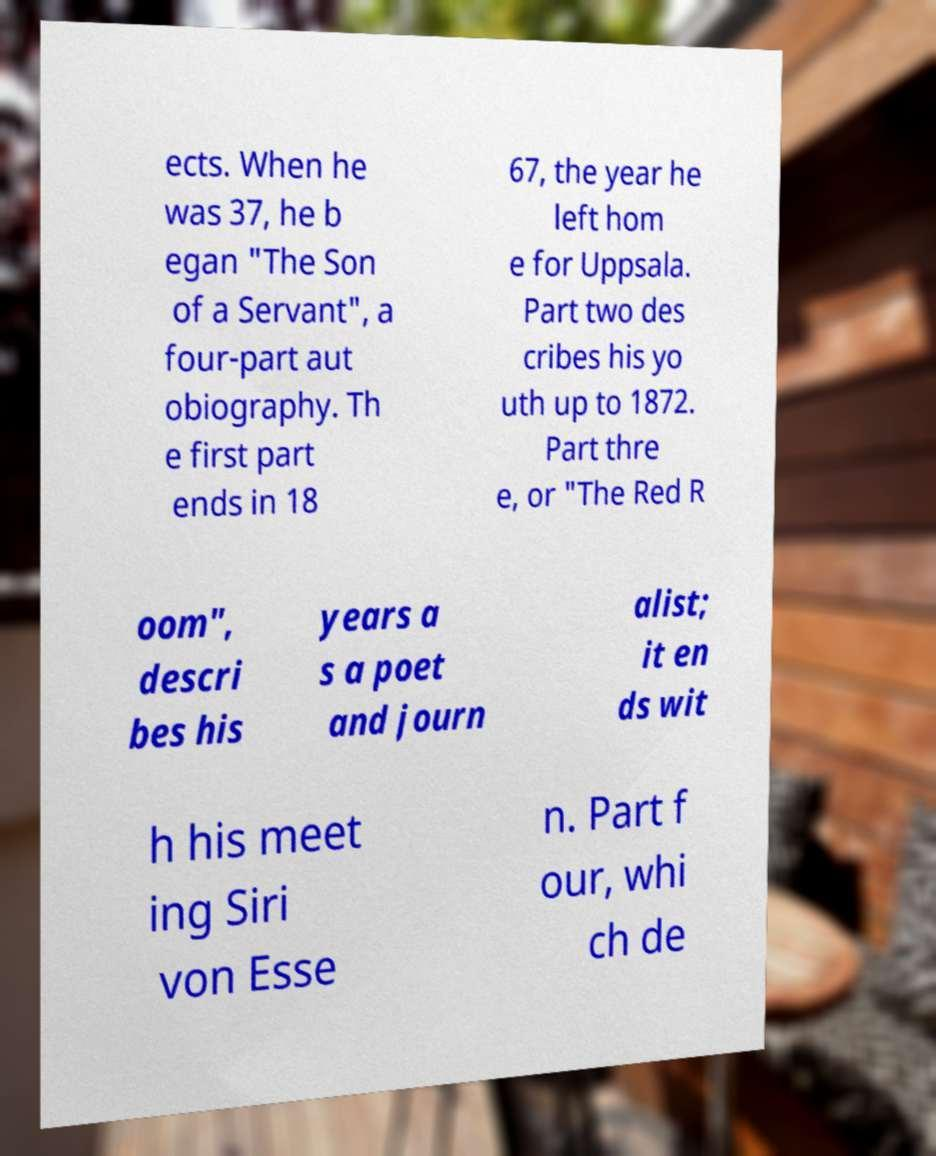For documentation purposes, I need the text within this image transcribed. Could you provide that? ects. When he was 37, he b egan "The Son of a Servant", a four-part aut obiography. Th e first part ends in 18 67, the year he left hom e for Uppsala. Part two des cribes his yo uth up to 1872. Part thre e, or "The Red R oom", descri bes his years a s a poet and journ alist; it en ds wit h his meet ing Siri von Esse n. Part f our, whi ch de 